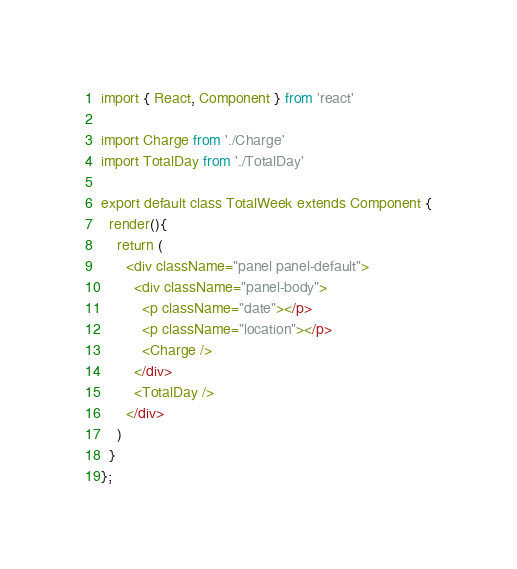Convert code to text. <code><loc_0><loc_0><loc_500><loc_500><_JavaScript_>import { React, Component } from 'react'

import Charge from './Charge'
import TotalDay from './TotalDay'

export default class TotalWeek extends Component {
  render(){
    return (
      <div className="panel panel-default">
        <div className="panel-body">
          <p className="date"></p>
          <p className="location"></p>
          <Charge />
        </div>
        <TotalDay />
      </div>
    )
  }
};
</code> 